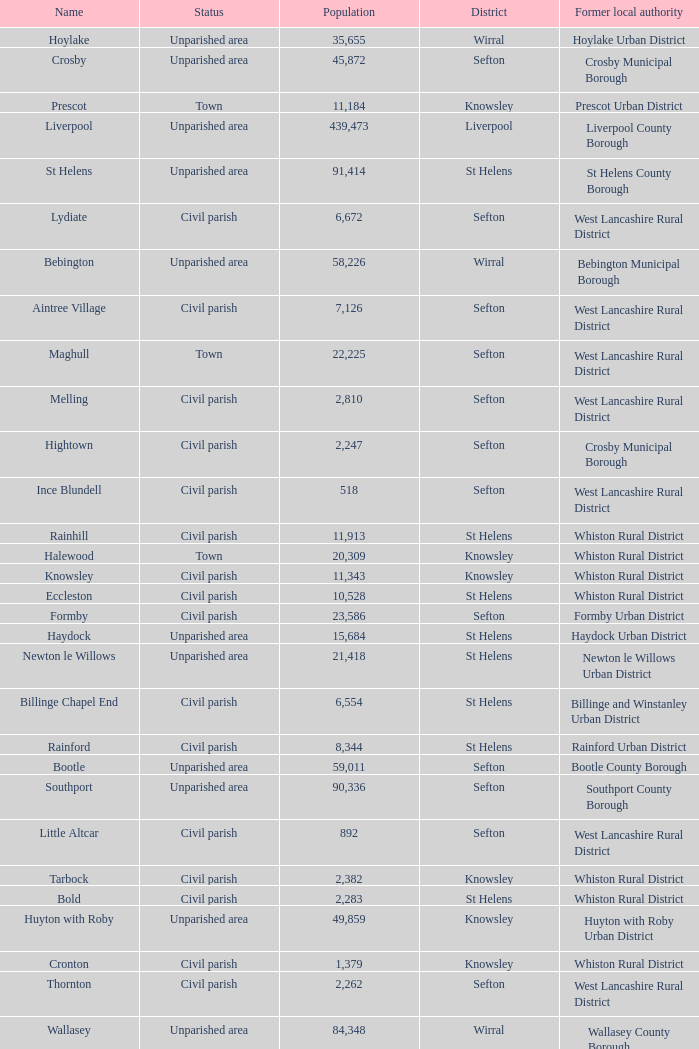What is the district of wallasey Wirral. 